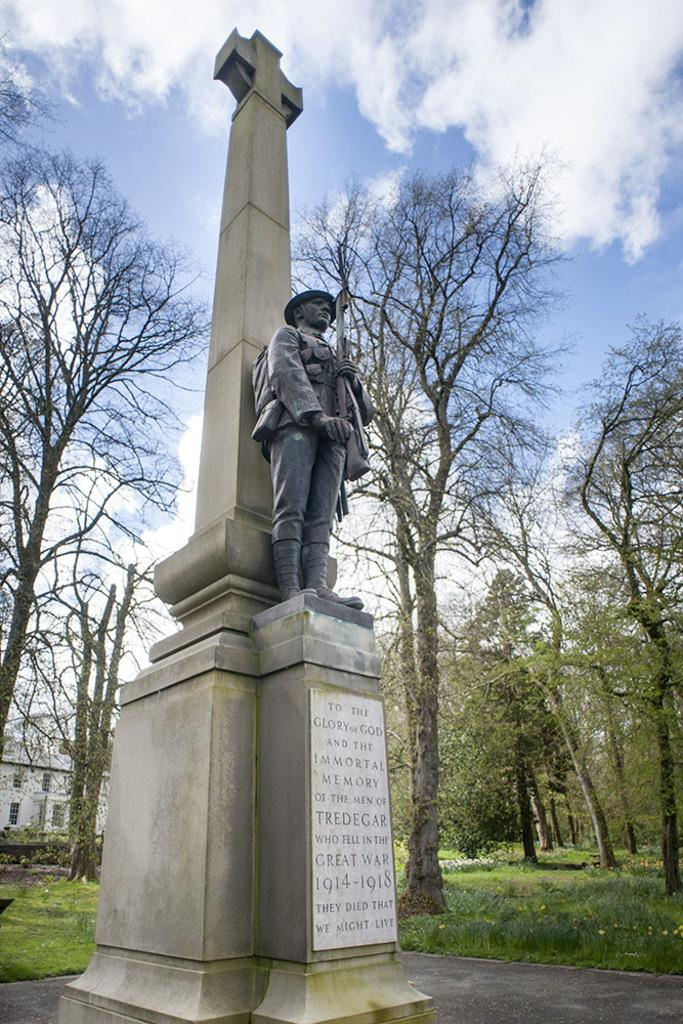What is the main subject of the image? There is a statue of a person in the image. What can be seen in the background of the image? There are trees, a building, grass, and the sky visible in the background of the image. What other object is present in the image? There is a memorial stone in the image. What is written on the memorial stone? Something is written on the memorial stone. How many cows are grazing in the background of the image? There are no cows present in the image. What type of lock is securing the memorial stone in the image? There is no lock present on the memorial stone in the image. 